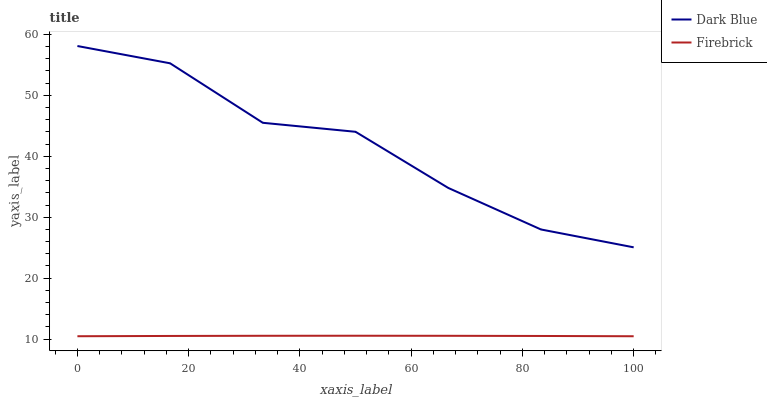Does Firebrick have the minimum area under the curve?
Answer yes or no. Yes. Does Dark Blue have the maximum area under the curve?
Answer yes or no. Yes. Does Firebrick have the maximum area under the curve?
Answer yes or no. No. Is Firebrick the smoothest?
Answer yes or no. Yes. Is Dark Blue the roughest?
Answer yes or no. Yes. Is Firebrick the roughest?
Answer yes or no. No. Does Firebrick have the lowest value?
Answer yes or no. Yes. Does Dark Blue have the highest value?
Answer yes or no. Yes. Does Firebrick have the highest value?
Answer yes or no. No. Is Firebrick less than Dark Blue?
Answer yes or no. Yes. Is Dark Blue greater than Firebrick?
Answer yes or no. Yes. Does Firebrick intersect Dark Blue?
Answer yes or no. No. 